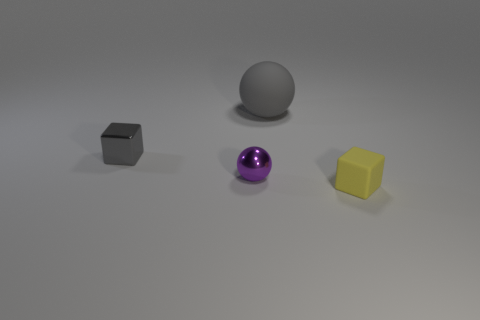Subtract all brown cubes. Subtract all cyan spheres. How many cubes are left? 2 Add 3 tiny cubes. How many objects exist? 7 Subtract 0 blue balls. How many objects are left? 4 Subtract all purple objects. Subtract all gray shiny things. How many objects are left? 2 Add 2 tiny purple objects. How many tiny purple objects are left? 3 Add 1 tiny gray blocks. How many tiny gray blocks exist? 2 